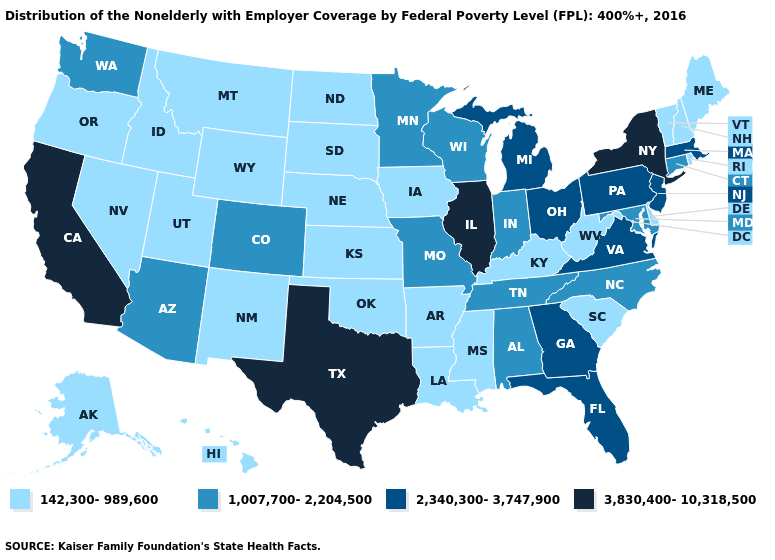Does Georgia have the same value as Louisiana?
Concise answer only. No. Does Kansas have a lower value than Iowa?
Short answer required. No. Name the states that have a value in the range 3,830,400-10,318,500?
Keep it brief. California, Illinois, New York, Texas. Name the states that have a value in the range 3,830,400-10,318,500?
Give a very brief answer. California, Illinois, New York, Texas. What is the value of Washington?
Answer briefly. 1,007,700-2,204,500. What is the value of Rhode Island?
Write a very short answer. 142,300-989,600. Name the states that have a value in the range 3,830,400-10,318,500?
Keep it brief. California, Illinois, New York, Texas. What is the lowest value in the USA?
Concise answer only. 142,300-989,600. Among the states that border Connecticut , which have the highest value?
Keep it brief. New York. What is the highest value in the USA?
Quick response, please. 3,830,400-10,318,500. Name the states that have a value in the range 1,007,700-2,204,500?
Answer briefly. Alabama, Arizona, Colorado, Connecticut, Indiana, Maryland, Minnesota, Missouri, North Carolina, Tennessee, Washington, Wisconsin. Name the states that have a value in the range 142,300-989,600?
Keep it brief. Alaska, Arkansas, Delaware, Hawaii, Idaho, Iowa, Kansas, Kentucky, Louisiana, Maine, Mississippi, Montana, Nebraska, Nevada, New Hampshire, New Mexico, North Dakota, Oklahoma, Oregon, Rhode Island, South Carolina, South Dakota, Utah, Vermont, West Virginia, Wyoming. What is the value of Missouri?
Short answer required. 1,007,700-2,204,500. Does Vermont have the same value as Kansas?
Quick response, please. Yes. Is the legend a continuous bar?
Be succinct. No. 